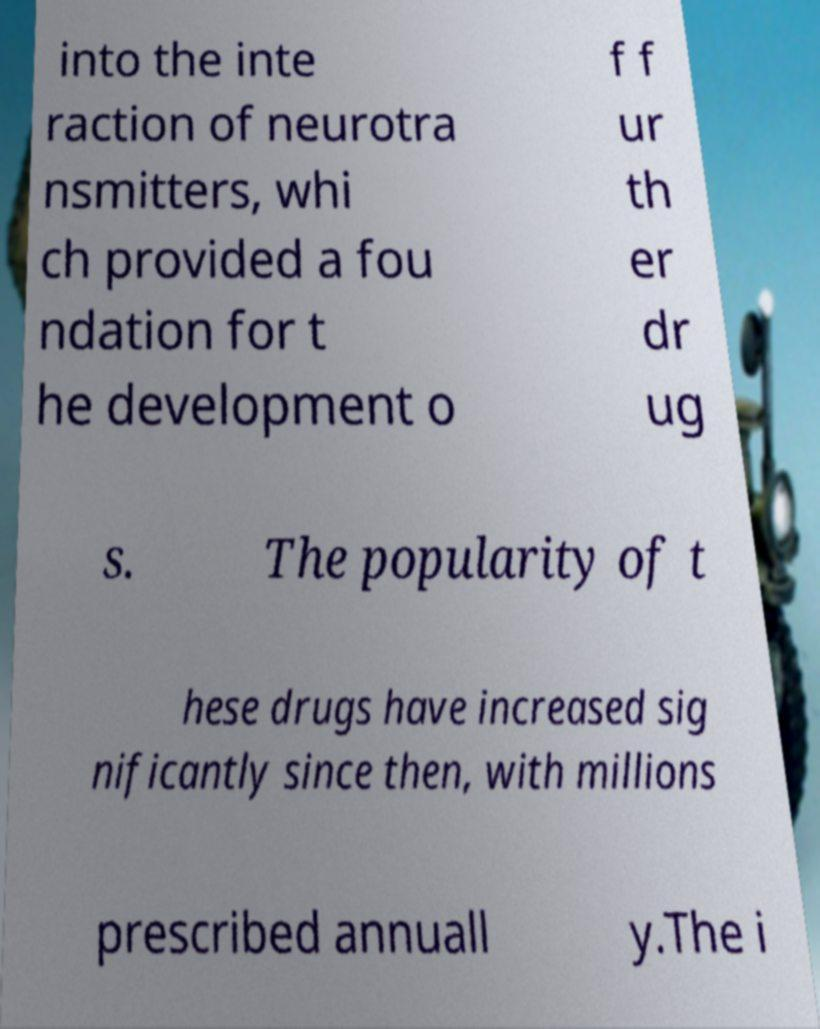What messages or text are displayed in this image? I need them in a readable, typed format. into the inte raction of neurotra nsmitters, whi ch provided a fou ndation for t he development o f f ur th er dr ug s. The popularity of t hese drugs have increased sig nificantly since then, with millions prescribed annuall y.The i 